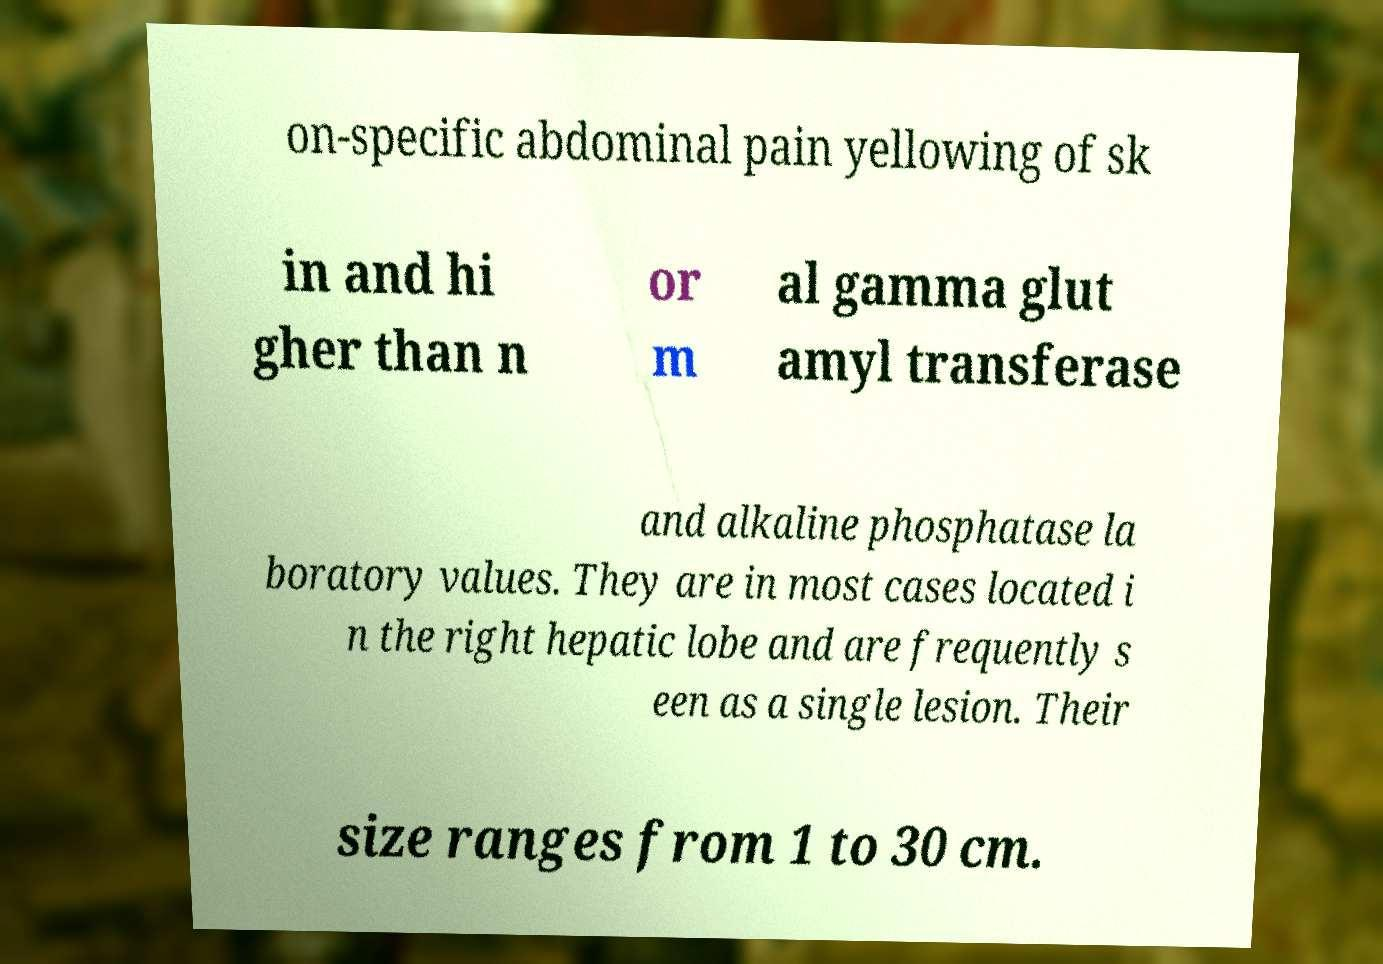Can you read and provide the text displayed in the image?This photo seems to have some interesting text. Can you extract and type it out for me? on-specific abdominal pain yellowing of sk in and hi gher than n or m al gamma glut amyl transferase and alkaline phosphatase la boratory values. They are in most cases located i n the right hepatic lobe and are frequently s een as a single lesion. Their size ranges from 1 to 30 cm. 